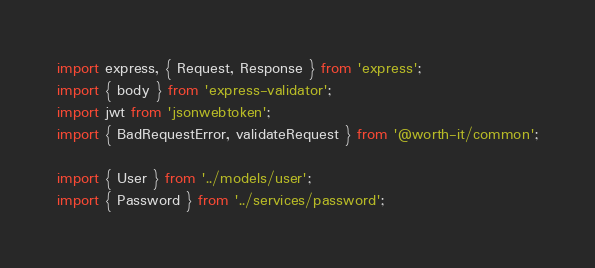Convert code to text. <code><loc_0><loc_0><loc_500><loc_500><_TypeScript_>import express, { Request, Response } from 'express';
import { body } from 'express-validator';
import jwt from 'jsonwebtoken';
import { BadRequestError, validateRequest } from '@worth-it/common';

import { User } from '../models/user';
import { Password } from '../services/password';
</code> 